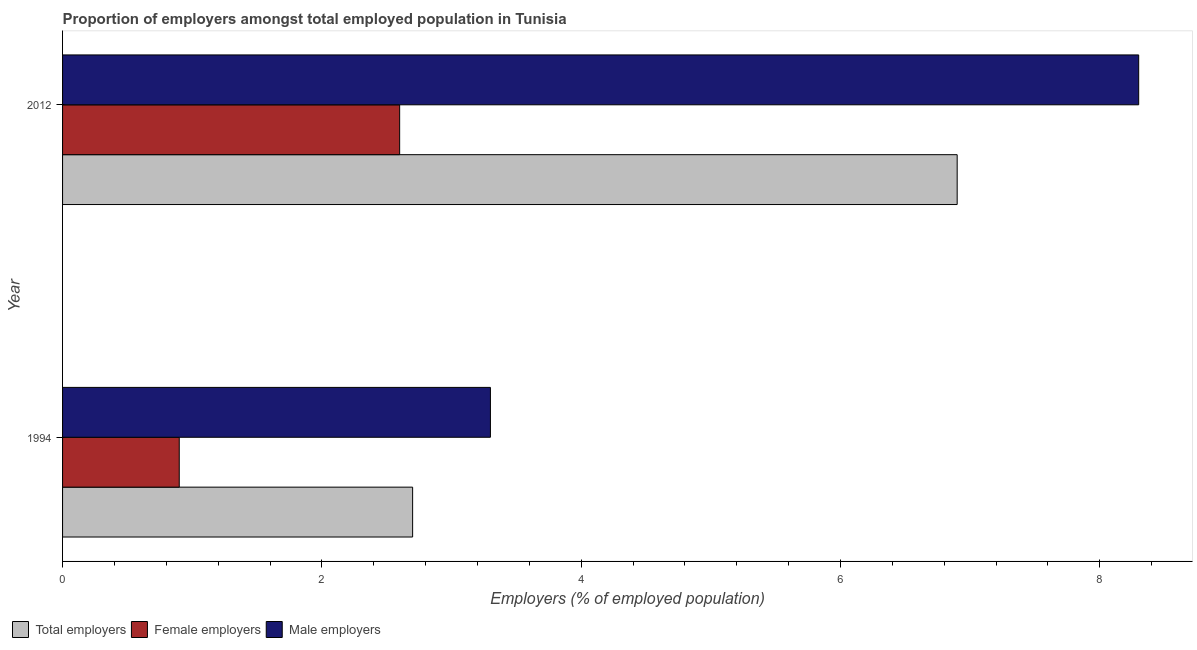How many different coloured bars are there?
Your answer should be compact. 3. How many bars are there on the 1st tick from the top?
Provide a succinct answer. 3. How many bars are there on the 1st tick from the bottom?
Make the answer very short. 3. In how many cases, is the number of bars for a given year not equal to the number of legend labels?
Provide a succinct answer. 0. What is the percentage of female employers in 1994?
Provide a succinct answer. 0.9. Across all years, what is the maximum percentage of total employers?
Provide a succinct answer. 6.9. Across all years, what is the minimum percentage of male employers?
Ensure brevity in your answer.  3.3. In which year was the percentage of male employers maximum?
Make the answer very short. 2012. In which year was the percentage of female employers minimum?
Ensure brevity in your answer.  1994. What is the total percentage of total employers in the graph?
Give a very brief answer. 9.6. What is the difference between the percentage of total employers in 1994 and the percentage of female employers in 2012?
Provide a succinct answer. 0.1. What is the ratio of the percentage of total employers in 1994 to that in 2012?
Your answer should be compact. 0.39. Is the percentage of male employers in 1994 less than that in 2012?
Ensure brevity in your answer.  Yes. In how many years, is the percentage of total employers greater than the average percentage of total employers taken over all years?
Give a very brief answer. 1. What does the 1st bar from the top in 1994 represents?
Make the answer very short. Male employers. What does the 2nd bar from the bottom in 2012 represents?
Provide a succinct answer. Female employers. Is it the case that in every year, the sum of the percentage of total employers and percentage of female employers is greater than the percentage of male employers?
Provide a succinct answer. Yes. Are all the bars in the graph horizontal?
Your response must be concise. Yes. How many years are there in the graph?
Your response must be concise. 2. What is the difference between two consecutive major ticks on the X-axis?
Your response must be concise. 2. Are the values on the major ticks of X-axis written in scientific E-notation?
Offer a terse response. No. Where does the legend appear in the graph?
Provide a succinct answer. Bottom left. How many legend labels are there?
Provide a succinct answer. 3. What is the title of the graph?
Ensure brevity in your answer.  Proportion of employers amongst total employed population in Tunisia. What is the label or title of the X-axis?
Give a very brief answer. Employers (% of employed population). What is the label or title of the Y-axis?
Keep it short and to the point. Year. What is the Employers (% of employed population) in Total employers in 1994?
Your answer should be compact. 2.7. What is the Employers (% of employed population) of Female employers in 1994?
Ensure brevity in your answer.  0.9. What is the Employers (% of employed population) of Male employers in 1994?
Provide a short and direct response. 3.3. What is the Employers (% of employed population) in Total employers in 2012?
Ensure brevity in your answer.  6.9. What is the Employers (% of employed population) of Female employers in 2012?
Your response must be concise. 2.6. What is the Employers (% of employed population) of Male employers in 2012?
Give a very brief answer. 8.3. Across all years, what is the maximum Employers (% of employed population) of Total employers?
Give a very brief answer. 6.9. Across all years, what is the maximum Employers (% of employed population) in Female employers?
Give a very brief answer. 2.6. Across all years, what is the maximum Employers (% of employed population) of Male employers?
Ensure brevity in your answer.  8.3. Across all years, what is the minimum Employers (% of employed population) in Total employers?
Make the answer very short. 2.7. Across all years, what is the minimum Employers (% of employed population) in Female employers?
Provide a succinct answer. 0.9. Across all years, what is the minimum Employers (% of employed population) in Male employers?
Offer a very short reply. 3.3. What is the total Employers (% of employed population) in Female employers in the graph?
Provide a succinct answer. 3.5. What is the difference between the Employers (% of employed population) of Total employers in 1994 and that in 2012?
Offer a terse response. -4.2. What is the difference between the Employers (% of employed population) of Female employers in 1994 and that in 2012?
Give a very brief answer. -1.7. What is the difference between the Employers (% of employed population) in Male employers in 1994 and that in 2012?
Offer a very short reply. -5. What is the average Employers (% of employed population) in Female employers per year?
Give a very brief answer. 1.75. In the year 1994, what is the difference between the Employers (% of employed population) of Total employers and Employers (% of employed population) of Male employers?
Ensure brevity in your answer.  -0.6. In the year 1994, what is the difference between the Employers (% of employed population) of Female employers and Employers (% of employed population) of Male employers?
Keep it short and to the point. -2.4. In the year 2012, what is the difference between the Employers (% of employed population) in Total employers and Employers (% of employed population) in Female employers?
Provide a succinct answer. 4.3. What is the ratio of the Employers (% of employed population) in Total employers in 1994 to that in 2012?
Your answer should be compact. 0.39. What is the ratio of the Employers (% of employed population) in Female employers in 1994 to that in 2012?
Give a very brief answer. 0.35. What is the ratio of the Employers (% of employed population) in Male employers in 1994 to that in 2012?
Your response must be concise. 0.4. What is the difference between the highest and the second highest Employers (% of employed population) in Total employers?
Offer a terse response. 4.2. What is the difference between the highest and the second highest Employers (% of employed population) in Female employers?
Offer a very short reply. 1.7. What is the difference between the highest and the second highest Employers (% of employed population) in Male employers?
Your response must be concise. 5. What is the difference between the highest and the lowest Employers (% of employed population) of Total employers?
Ensure brevity in your answer.  4.2. What is the difference between the highest and the lowest Employers (% of employed population) in Female employers?
Offer a very short reply. 1.7. 